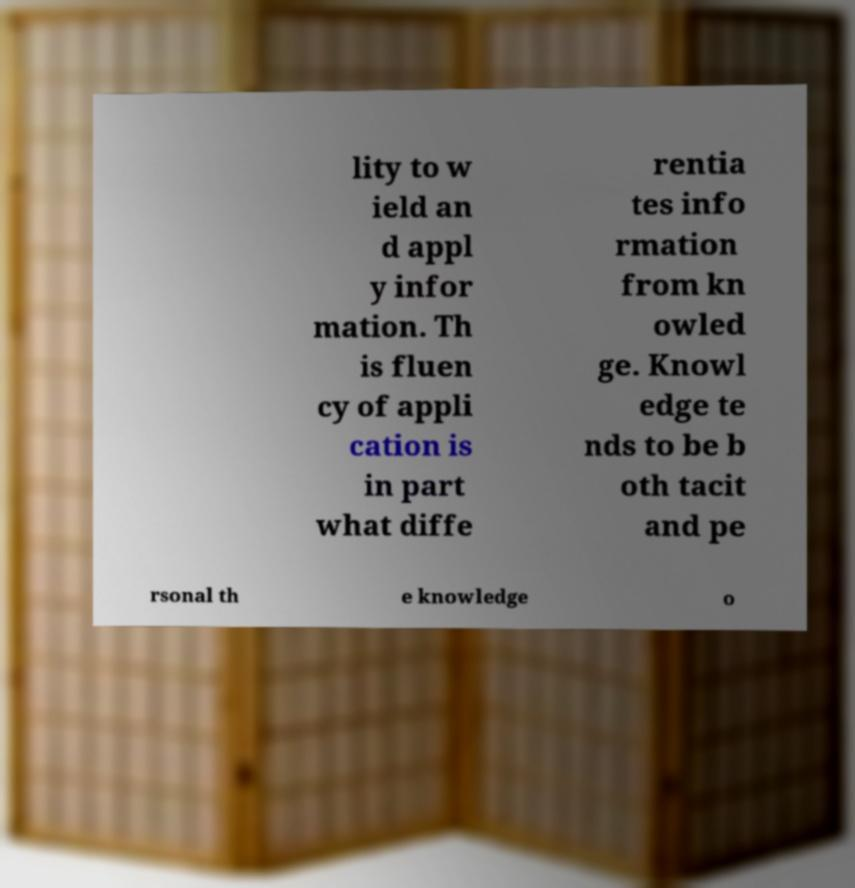Could you extract and type out the text from this image? lity to w ield an d appl y infor mation. Th is fluen cy of appli cation is in part what diffe rentia tes info rmation from kn owled ge. Knowl edge te nds to be b oth tacit and pe rsonal th e knowledge o 